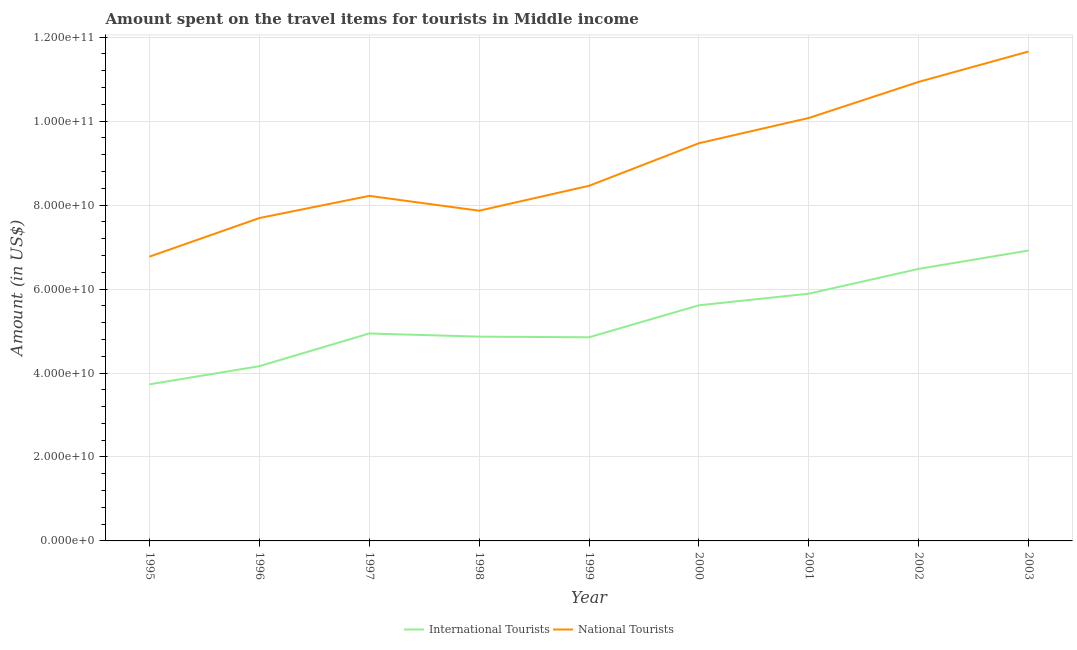How many different coloured lines are there?
Make the answer very short. 2. Does the line corresponding to amount spent on travel items of national tourists intersect with the line corresponding to amount spent on travel items of international tourists?
Ensure brevity in your answer.  No. What is the amount spent on travel items of international tourists in 1996?
Offer a terse response. 4.16e+1. Across all years, what is the maximum amount spent on travel items of national tourists?
Provide a succinct answer. 1.17e+11. Across all years, what is the minimum amount spent on travel items of international tourists?
Give a very brief answer. 3.73e+1. In which year was the amount spent on travel items of international tourists maximum?
Give a very brief answer. 2003. In which year was the amount spent on travel items of international tourists minimum?
Make the answer very short. 1995. What is the total amount spent on travel items of national tourists in the graph?
Keep it short and to the point. 8.11e+11. What is the difference between the amount spent on travel items of international tourists in 1997 and that in 1999?
Offer a very short reply. 9.06e+08. What is the difference between the amount spent on travel items of international tourists in 2001 and the amount spent on travel items of national tourists in 1995?
Your response must be concise. -8.82e+09. What is the average amount spent on travel items of international tourists per year?
Provide a succinct answer. 5.27e+1. In the year 2000, what is the difference between the amount spent on travel items of national tourists and amount spent on travel items of international tourists?
Provide a short and direct response. 3.86e+1. What is the ratio of the amount spent on travel items of international tourists in 1995 to that in 2000?
Your response must be concise. 0.66. What is the difference between the highest and the second highest amount spent on travel items of national tourists?
Your answer should be very brief. 7.23e+09. What is the difference between the highest and the lowest amount spent on travel items of national tourists?
Your response must be concise. 4.89e+1. In how many years, is the amount spent on travel items of national tourists greater than the average amount spent on travel items of national tourists taken over all years?
Your answer should be very brief. 4. Does the amount spent on travel items of international tourists monotonically increase over the years?
Your answer should be compact. No. Are the values on the major ticks of Y-axis written in scientific E-notation?
Keep it short and to the point. Yes. Does the graph contain any zero values?
Provide a succinct answer. No. Does the graph contain grids?
Make the answer very short. Yes. What is the title of the graph?
Offer a very short reply. Amount spent on the travel items for tourists in Middle income. What is the label or title of the X-axis?
Provide a short and direct response. Year. What is the Amount (in US$) of International Tourists in 1995?
Provide a succinct answer. 3.73e+1. What is the Amount (in US$) of National Tourists in 1995?
Your response must be concise. 6.77e+1. What is the Amount (in US$) of International Tourists in 1996?
Your answer should be very brief. 4.16e+1. What is the Amount (in US$) of National Tourists in 1996?
Keep it short and to the point. 7.69e+1. What is the Amount (in US$) of International Tourists in 1997?
Offer a very short reply. 4.94e+1. What is the Amount (in US$) of National Tourists in 1997?
Offer a very short reply. 8.22e+1. What is the Amount (in US$) of International Tourists in 1998?
Your answer should be very brief. 4.87e+1. What is the Amount (in US$) of National Tourists in 1998?
Your response must be concise. 7.87e+1. What is the Amount (in US$) in International Tourists in 1999?
Keep it short and to the point. 4.85e+1. What is the Amount (in US$) of National Tourists in 1999?
Your response must be concise. 8.46e+1. What is the Amount (in US$) of International Tourists in 2000?
Your answer should be compact. 5.61e+1. What is the Amount (in US$) in National Tourists in 2000?
Keep it short and to the point. 9.47e+1. What is the Amount (in US$) of International Tourists in 2001?
Keep it short and to the point. 5.89e+1. What is the Amount (in US$) in National Tourists in 2001?
Your answer should be very brief. 1.01e+11. What is the Amount (in US$) of International Tourists in 2002?
Keep it short and to the point. 6.48e+1. What is the Amount (in US$) in National Tourists in 2002?
Your response must be concise. 1.09e+11. What is the Amount (in US$) in International Tourists in 2003?
Provide a short and direct response. 6.92e+1. What is the Amount (in US$) in National Tourists in 2003?
Provide a short and direct response. 1.17e+11. Across all years, what is the maximum Amount (in US$) in International Tourists?
Provide a short and direct response. 6.92e+1. Across all years, what is the maximum Amount (in US$) in National Tourists?
Ensure brevity in your answer.  1.17e+11. Across all years, what is the minimum Amount (in US$) of International Tourists?
Your response must be concise. 3.73e+1. Across all years, what is the minimum Amount (in US$) of National Tourists?
Keep it short and to the point. 6.77e+1. What is the total Amount (in US$) in International Tourists in the graph?
Give a very brief answer. 4.75e+11. What is the total Amount (in US$) in National Tourists in the graph?
Provide a succinct answer. 8.11e+11. What is the difference between the Amount (in US$) of International Tourists in 1995 and that in 1996?
Keep it short and to the point. -4.33e+09. What is the difference between the Amount (in US$) of National Tourists in 1995 and that in 1996?
Give a very brief answer. -9.19e+09. What is the difference between the Amount (in US$) of International Tourists in 1995 and that in 1997?
Give a very brief answer. -1.21e+1. What is the difference between the Amount (in US$) in National Tourists in 1995 and that in 1997?
Provide a succinct answer. -1.45e+1. What is the difference between the Amount (in US$) in International Tourists in 1995 and that in 1998?
Provide a short and direct response. -1.14e+1. What is the difference between the Amount (in US$) of National Tourists in 1995 and that in 1998?
Ensure brevity in your answer.  -1.09e+1. What is the difference between the Amount (in US$) of International Tourists in 1995 and that in 1999?
Your response must be concise. -1.12e+1. What is the difference between the Amount (in US$) in National Tourists in 1995 and that in 1999?
Ensure brevity in your answer.  -1.69e+1. What is the difference between the Amount (in US$) of International Tourists in 1995 and that in 2000?
Keep it short and to the point. -1.88e+1. What is the difference between the Amount (in US$) of National Tourists in 1995 and that in 2000?
Your answer should be very brief. -2.70e+1. What is the difference between the Amount (in US$) of International Tourists in 1995 and that in 2001?
Ensure brevity in your answer.  -2.16e+1. What is the difference between the Amount (in US$) in National Tourists in 1995 and that in 2001?
Offer a terse response. -3.30e+1. What is the difference between the Amount (in US$) of International Tourists in 1995 and that in 2002?
Give a very brief answer. -2.75e+1. What is the difference between the Amount (in US$) in National Tourists in 1995 and that in 2002?
Offer a terse response. -4.16e+1. What is the difference between the Amount (in US$) in International Tourists in 1995 and that in 2003?
Your response must be concise. -3.19e+1. What is the difference between the Amount (in US$) of National Tourists in 1995 and that in 2003?
Ensure brevity in your answer.  -4.89e+1. What is the difference between the Amount (in US$) in International Tourists in 1996 and that in 1997?
Your answer should be compact. -7.79e+09. What is the difference between the Amount (in US$) in National Tourists in 1996 and that in 1997?
Provide a succinct answer. -5.28e+09. What is the difference between the Amount (in US$) of International Tourists in 1996 and that in 1998?
Your response must be concise. -7.04e+09. What is the difference between the Amount (in US$) in National Tourists in 1996 and that in 1998?
Give a very brief answer. -1.75e+09. What is the difference between the Amount (in US$) in International Tourists in 1996 and that in 1999?
Your answer should be very brief. -6.88e+09. What is the difference between the Amount (in US$) of National Tourists in 1996 and that in 1999?
Give a very brief answer. -7.68e+09. What is the difference between the Amount (in US$) of International Tourists in 1996 and that in 2000?
Keep it short and to the point. -1.45e+1. What is the difference between the Amount (in US$) in National Tourists in 1996 and that in 2000?
Ensure brevity in your answer.  -1.78e+1. What is the difference between the Amount (in US$) in International Tourists in 1996 and that in 2001?
Offer a very short reply. -1.73e+1. What is the difference between the Amount (in US$) in National Tourists in 1996 and that in 2001?
Give a very brief answer. -2.38e+1. What is the difference between the Amount (in US$) of International Tourists in 1996 and that in 2002?
Offer a terse response. -2.32e+1. What is the difference between the Amount (in US$) of National Tourists in 1996 and that in 2002?
Offer a very short reply. -3.24e+1. What is the difference between the Amount (in US$) in International Tourists in 1996 and that in 2003?
Make the answer very short. -2.76e+1. What is the difference between the Amount (in US$) in National Tourists in 1996 and that in 2003?
Your response must be concise. -3.97e+1. What is the difference between the Amount (in US$) in International Tourists in 1997 and that in 1998?
Your answer should be compact. 7.52e+08. What is the difference between the Amount (in US$) of National Tourists in 1997 and that in 1998?
Provide a short and direct response. 3.53e+09. What is the difference between the Amount (in US$) in International Tourists in 1997 and that in 1999?
Give a very brief answer. 9.06e+08. What is the difference between the Amount (in US$) in National Tourists in 1997 and that in 1999?
Offer a very short reply. -2.40e+09. What is the difference between the Amount (in US$) in International Tourists in 1997 and that in 2000?
Give a very brief answer. -6.71e+09. What is the difference between the Amount (in US$) of National Tourists in 1997 and that in 2000?
Offer a very short reply. -1.25e+1. What is the difference between the Amount (in US$) of International Tourists in 1997 and that in 2001?
Make the answer very short. -9.48e+09. What is the difference between the Amount (in US$) of National Tourists in 1997 and that in 2001?
Offer a very short reply. -1.86e+1. What is the difference between the Amount (in US$) of International Tourists in 1997 and that in 2002?
Provide a short and direct response. -1.54e+1. What is the difference between the Amount (in US$) of National Tourists in 1997 and that in 2002?
Provide a succinct answer. -2.72e+1. What is the difference between the Amount (in US$) in International Tourists in 1997 and that in 2003?
Provide a succinct answer. -1.98e+1. What is the difference between the Amount (in US$) of National Tourists in 1997 and that in 2003?
Give a very brief answer. -3.44e+1. What is the difference between the Amount (in US$) of International Tourists in 1998 and that in 1999?
Offer a very short reply. 1.54e+08. What is the difference between the Amount (in US$) of National Tourists in 1998 and that in 1999?
Provide a succinct answer. -5.93e+09. What is the difference between the Amount (in US$) of International Tourists in 1998 and that in 2000?
Provide a short and direct response. -7.47e+09. What is the difference between the Amount (in US$) of National Tourists in 1998 and that in 2000?
Provide a succinct answer. -1.61e+1. What is the difference between the Amount (in US$) of International Tourists in 1998 and that in 2001?
Make the answer very short. -1.02e+1. What is the difference between the Amount (in US$) in National Tourists in 1998 and that in 2001?
Your answer should be very brief. -2.21e+1. What is the difference between the Amount (in US$) of International Tourists in 1998 and that in 2002?
Offer a terse response. -1.61e+1. What is the difference between the Amount (in US$) in National Tourists in 1998 and that in 2002?
Your answer should be compact. -3.07e+1. What is the difference between the Amount (in US$) in International Tourists in 1998 and that in 2003?
Your answer should be very brief. -2.05e+1. What is the difference between the Amount (in US$) in National Tourists in 1998 and that in 2003?
Keep it short and to the point. -3.79e+1. What is the difference between the Amount (in US$) of International Tourists in 1999 and that in 2000?
Provide a succinct answer. -7.62e+09. What is the difference between the Amount (in US$) of National Tourists in 1999 and that in 2000?
Provide a succinct answer. -1.01e+1. What is the difference between the Amount (in US$) of International Tourists in 1999 and that in 2001?
Your answer should be very brief. -1.04e+1. What is the difference between the Amount (in US$) of National Tourists in 1999 and that in 2001?
Offer a very short reply. -1.62e+1. What is the difference between the Amount (in US$) in International Tourists in 1999 and that in 2002?
Keep it short and to the point. -1.63e+1. What is the difference between the Amount (in US$) of National Tourists in 1999 and that in 2002?
Your response must be concise. -2.48e+1. What is the difference between the Amount (in US$) of International Tourists in 1999 and that in 2003?
Your response must be concise. -2.07e+1. What is the difference between the Amount (in US$) of National Tourists in 1999 and that in 2003?
Make the answer very short. -3.20e+1. What is the difference between the Amount (in US$) of International Tourists in 2000 and that in 2001?
Provide a short and direct response. -2.77e+09. What is the difference between the Amount (in US$) in National Tourists in 2000 and that in 2001?
Your answer should be compact. -6.01e+09. What is the difference between the Amount (in US$) of International Tourists in 2000 and that in 2002?
Your answer should be very brief. -8.68e+09. What is the difference between the Amount (in US$) in National Tourists in 2000 and that in 2002?
Your answer should be very brief. -1.46e+1. What is the difference between the Amount (in US$) of International Tourists in 2000 and that in 2003?
Give a very brief answer. -1.31e+1. What is the difference between the Amount (in US$) of National Tourists in 2000 and that in 2003?
Your answer should be very brief. -2.18e+1. What is the difference between the Amount (in US$) of International Tourists in 2001 and that in 2002?
Offer a terse response. -5.91e+09. What is the difference between the Amount (in US$) of National Tourists in 2001 and that in 2002?
Your answer should be very brief. -8.60e+09. What is the difference between the Amount (in US$) in International Tourists in 2001 and that in 2003?
Provide a short and direct response. -1.03e+1. What is the difference between the Amount (in US$) of National Tourists in 2001 and that in 2003?
Your answer should be compact. -1.58e+1. What is the difference between the Amount (in US$) in International Tourists in 2002 and that in 2003?
Give a very brief answer. -4.37e+09. What is the difference between the Amount (in US$) in National Tourists in 2002 and that in 2003?
Your answer should be very brief. -7.23e+09. What is the difference between the Amount (in US$) of International Tourists in 1995 and the Amount (in US$) of National Tourists in 1996?
Keep it short and to the point. -3.96e+1. What is the difference between the Amount (in US$) of International Tourists in 1995 and the Amount (in US$) of National Tourists in 1997?
Ensure brevity in your answer.  -4.49e+1. What is the difference between the Amount (in US$) in International Tourists in 1995 and the Amount (in US$) in National Tourists in 1998?
Provide a short and direct response. -4.14e+1. What is the difference between the Amount (in US$) in International Tourists in 1995 and the Amount (in US$) in National Tourists in 1999?
Offer a terse response. -4.73e+1. What is the difference between the Amount (in US$) of International Tourists in 1995 and the Amount (in US$) of National Tourists in 2000?
Your answer should be very brief. -5.74e+1. What is the difference between the Amount (in US$) in International Tourists in 1995 and the Amount (in US$) in National Tourists in 2001?
Your answer should be compact. -6.34e+1. What is the difference between the Amount (in US$) of International Tourists in 1995 and the Amount (in US$) of National Tourists in 2002?
Offer a very short reply. -7.20e+1. What is the difference between the Amount (in US$) in International Tourists in 1995 and the Amount (in US$) in National Tourists in 2003?
Offer a terse response. -7.93e+1. What is the difference between the Amount (in US$) of International Tourists in 1996 and the Amount (in US$) of National Tourists in 1997?
Provide a succinct answer. -4.06e+1. What is the difference between the Amount (in US$) in International Tourists in 1996 and the Amount (in US$) in National Tourists in 1998?
Ensure brevity in your answer.  -3.70e+1. What is the difference between the Amount (in US$) in International Tourists in 1996 and the Amount (in US$) in National Tourists in 1999?
Provide a succinct answer. -4.30e+1. What is the difference between the Amount (in US$) in International Tourists in 1996 and the Amount (in US$) in National Tourists in 2000?
Ensure brevity in your answer.  -5.31e+1. What is the difference between the Amount (in US$) in International Tourists in 1996 and the Amount (in US$) in National Tourists in 2001?
Ensure brevity in your answer.  -5.91e+1. What is the difference between the Amount (in US$) in International Tourists in 1996 and the Amount (in US$) in National Tourists in 2002?
Keep it short and to the point. -6.77e+1. What is the difference between the Amount (in US$) in International Tourists in 1996 and the Amount (in US$) in National Tourists in 2003?
Make the answer very short. -7.50e+1. What is the difference between the Amount (in US$) of International Tourists in 1997 and the Amount (in US$) of National Tourists in 1998?
Your answer should be compact. -2.92e+1. What is the difference between the Amount (in US$) of International Tourists in 1997 and the Amount (in US$) of National Tourists in 1999?
Make the answer very short. -3.52e+1. What is the difference between the Amount (in US$) in International Tourists in 1997 and the Amount (in US$) in National Tourists in 2000?
Your response must be concise. -4.53e+1. What is the difference between the Amount (in US$) in International Tourists in 1997 and the Amount (in US$) in National Tourists in 2001?
Offer a terse response. -5.13e+1. What is the difference between the Amount (in US$) of International Tourists in 1997 and the Amount (in US$) of National Tourists in 2002?
Your answer should be very brief. -5.99e+1. What is the difference between the Amount (in US$) of International Tourists in 1997 and the Amount (in US$) of National Tourists in 2003?
Offer a very short reply. -6.72e+1. What is the difference between the Amount (in US$) of International Tourists in 1998 and the Amount (in US$) of National Tourists in 1999?
Keep it short and to the point. -3.59e+1. What is the difference between the Amount (in US$) of International Tourists in 1998 and the Amount (in US$) of National Tourists in 2000?
Offer a very short reply. -4.61e+1. What is the difference between the Amount (in US$) in International Tourists in 1998 and the Amount (in US$) in National Tourists in 2001?
Your response must be concise. -5.21e+1. What is the difference between the Amount (in US$) of International Tourists in 1998 and the Amount (in US$) of National Tourists in 2002?
Your answer should be compact. -6.07e+1. What is the difference between the Amount (in US$) in International Tourists in 1998 and the Amount (in US$) in National Tourists in 2003?
Ensure brevity in your answer.  -6.79e+1. What is the difference between the Amount (in US$) of International Tourists in 1999 and the Amount (in US$) of National Tourists in 2000?
Keep it short and to the point. -4.62e+1. What is the difference between the Amount (in US$) of International Tourists in 1999 and the Amount (in US$) of National Tourists in 2001?
Make the answer very short. -5.22e+1. What is the difference between the Amount (in US$) of International Tourists in 1999 and the Amount (in US$) of National Tourists in 2002?
Your response must be concise. -6.08e+1. What is the difference between the Amount (in US$) of International Tourists in 1999 and the Amount (in US$) of National Tourists in 2003?
Keep it short and to the point. -6.81e+1. What is the difference between the Amount (in US$) of International Tourists in 2000 and the Amount (in US$) of National Tourists in 2001?
Offer a very short reply. -4.46e+1. What is the difference between the Amount (in US$) in International Tourists in 2000 and the Amount (in US$) in National Tourists in 2002?
Provide a succinct answer. -5.32e+1. What is the difference between the Amount (in US$) of International Tourists in 2000 and the Amount (in US$) of National Tourists in 2003?
Your answer should be compact. -6.05e+1. What is the difference between the Amount (in US$) in International Tourists in 2001 and the Amount (in US$) in National Tourists in 2002?
Make the answer very short. -5.05e+1. What is the difference between the Amount (in US$) of International Tourists in 2001 and the Amount (in US$) of National Tourists in 2003?
Make the answer very short. -5.77e+1. What is the difference between the Amount (in US$) in International Tourists in 2002 and the Amount (in US$) in National Tourists in 2003?
Your response must be concise. -5.18e+1. What is the average Amount (in US$) in International Tourists per year?
Ensure brevity in your answer.  5.27e+1. What is the average Amount (in US$) of National Tourists per year?
Provide a short and direct response. 9.02e+1. In the year 1995, what is the difference between the Amount (in US$) of International Tourists and Amount (in US$) of National Tourists?
Keep it short and to the point. -3.04e+1. In the year 1996, what is the difference between the Amount (in US$) in International Tourists and Amount (in US$) in National Tourists?
Your answer should be very brief. -3.53e+1. In the year 1997, what is the difference between the Amount (in US$) of International Tourists and Amount (in US$) of National Tourists?
Your answer should be compact. -3.28e+1. In the year 1998, what is the difference between the Amount (in US$) of International Tourists and Amount (in US$) of National Tourists?
Ensure brevity in your answer.  -3.00e+1. In the year 1999, what is the difference between the Amount (in US$) in International Tourists and Amount (in US$) in National Tourists?
Provide a short and direct response. -3.61e+1. In the year 2000, what is the difference between the Amount (in US$) of International Tourists and Amount (in US$) of National Tourists?
Provide a short and direct response. -3.86e+1. In the year 2001, what is the difference between the Amount (in US$) of International Tourists and Amount (in US$) of National Tourists?
Your answer should be very brief. -4.19e+1. In the year 2002, what is the difference between the Amount (in US$) of International Tourists and Amount (in US$) of National Tourists?
Your response must be concise. -4.45e+1. In the year 2003, what is the difference between the Amount (in US$) of International Tourists and Amount (in US$) of National Tourists?
Ensure brevity in your answer.  -4.74e+1. What is the ratio of the Amount (in US$) in International Tourists in 1995 to that in 1996?
Make the answer very short. 0.9. What is the ratio of the Amount (in US$) of National Tourists in 1995 to that in 1996?
Ensure brevity in your answer.  0.88. What is the ratio of the Amount (in US$) of International Tourists in 1995 to that in 1997?
Your response must be concise. 0.75. What is the ratio of the Amount (in US$) in National Tourists in 1995 to that in 1997?
Your answer should be very brief. 0.82. What is the ratio of the Amount (in US$) in International Tourists in 1995 to that in 1998?
Provide a short and direct response. 0.77. What is the ratio of the Amount (in US$) of National Tourists in 1995 to that in 1998?
Your answer should be compact. 0.86. What is the ratio of the Amount (in US$) in International Tourists in 1995 to that in 1999?
Keep it short and to the point. 0.77. What is the ratio of the Amount (in US$) of National Tourists in 1995 to that in 1999?
Make the answer very short. 0.8. What is the ratio of the Amount (in US$) of International Tourists in 1995 to that in 2000?
Ensure brevity in your answer.  0.66. What is the ratio of the Amount (in US$) in National Tourists in 1995 to that in 2000?
Offer a terse response. 0.71. What is the ratio of the Amount (in US$) in International Tourists in 1995 to that in 2001?
Keep it short and to the point. 0.63. What is the ratio of the Amount (in US$) of National Tourists in 1995 to that in 2001?
Offer a terse response. 0.67. What is the ratio of the Amount (in US$) in International Tourists in 1995 to that in 2002?
Provide a succinct answer. 0.58. What is the ratio of the Amount (in US$) in National Tourists in 1995 to that in 2002?
Give a very brief answer. 0.62. What is the ratio of the Amount (in US$) in International Tourists in 1995 to that in 2003?
Keep it short and to the point. 0.54. What is the ratio of the Amount (in US$) in National Tourists in 1995 to that in 2003?
Your response must be concise. 0.58. What is the ratio of the Amount (in US$) in International Tourists in 1996 to that in 1997?
Your response must be concise. 0.84. What is the ratio of the Amount (in US$) in National Tourists in 1996 to that in 1997?
Keep it short and to the point. 0.94. What is the ratio of the Amount (in US$) of International Tourists in 1996 to that in 1998?
Your answer should be compact. 0.86. What is the ratio of the Amount (in US$) of National Tourists in 1996 to that in 1998?
Ensure brevity in your answer.  0.98. What is the ratio of the Amount (in US$) in International Tourists in 1996 to that in 1999?
Your response must be concise. 0.86. What is the ratio of the Amount (in US$) in National Tourists in 1996 to that in 1999?
Your answer should be very brief. 0.91. What is the ratio of the Amount (in US$) in International Tourists in 1996 to that in 2000?
Provide a short and direct response. 0.74. What is the ratio of the Amount (in US$) of National Tourists in 1996 to that in 2000?
Your response must be concise. 0.81. What is the ratio of the Amount (in US$) of International Tourists in 1996 to that in 2001?
Your response must be concise. 0.71. What is the ratio of the Amount (in US$) in National Tourists in 1996 to that in 2001?
Your response must be concise. 0.76. What is the ratio of the Amount (in US$) in International Tourists in 1996 to that in 2002?
Offer a very short reply. 0.64. What is the ratio of the Amount (in US$) of National Tourists in 1996 to that in 2002?
Your response must be concise. 0.7. What is the ratio of the Amount (in US$) of International Tourists in 1996 to that in 2003?
Your answer should be very brief. 0.6. What is the ratio of the Amount (in US$) in National Tourists in 1996 to that in 2003?
Offer a terse response. 0.66. What is the ratio of the Amount (in US$) of International Tourists in 1997 to that in 1998?
Give a very brief answer. 1.02. What is the ratio of the Amount (in US$) in National Tourists in 1997 to that in 1998?
Give a very brief answer. 1.04. What is the ratio of the Amount (in US$) in International Tourists in 1997 to that in 1999?
Your answer should be very brief. 1.02. What is the ratio of the Amount (in US$) of National Tourists in 1997 to that in 1999?
Your response must be concise. 0.97. What is the ratio of the Amount (in US$) in International Tourists in 1997 to that in 2000?
Your answer should be compact. 0.88. What is the ratio of the Amount (in US$) of National Tourists in 1997 to that in 2000?
Offer a terse response. 0.87. What is the ratio of the Amount (in US$) of International Tourists in 1997 to that in 2001?
Your answer should be compact. 0.84. What is the ratio of the Amount (in US$) in National Tourists in 1997 to that in 2001?
Ensure brevity in your answer.  0.82. What is the ratio of the Amount (in US$) of International Tourists in 1997 to that in 2002?
Your answer should be compact. 0.76. What is the ratio of the Amount (in US$) in National Tourists in 1997 to that in 2002?
Your response must be concise. 0.75. What is the ratio of the Amount (in US$) of National Tourists in 1997 to that in 2003?
Make the answer very short. 0.7. What is the ratio of the Amount (in US$) in International Tourists in 1998 to that in 1999?
Provide a short and direct response. 1. What is the ratio of the Amount (in US$) in National Tourists in 1998 to that in 1999?
Offer a terse response. 0.93. What is the ratio of the Amount (in US$) of International Tourists in 1998 to that in 2000?
Provide a succinct answer. 0.87. What is the ratio of the Amount (in US$) of National Tourists in 1998 to that in 2000?
Ensure brevity in your answer.  0.83. What is the ratio of the Amount (in US$) in International Tourists in 1998 to that in 2001?
Provide a short and direct response. 0.83. What is the ratio of the Amount (in US$) of National Tourists in 1998 to that in 2001?
Offer a very short reply. 0.78. What is the ratio of the Amount (in US$) of International Tourists in 1998 to that in 2002?
Your answer should be very brief. 0.75. What is the ratio of the Amount (in US$) of National Tourists in 1998 to that in 2002?
Provide a succinct answer. 0.72. What is the ratio of the Amount (in US$) of International Tourists in 1998 to that in 2003?
Provide a short and direct response. 0.7. What is the ratio of the Amount (in US$) of National Tourists in 1998 to that in 2003?
Your answer should be very brief. 0.67. What is the ratio of the Amount (in US$) in International Tourists in 1999 to that in 2000?
Give a very brief answer. 0.86. What is the ratio of the Amount (in US$) in National Tourists in 1999 to that in 2000?
Your answer should be very brief. 0.89. What is the ratio of the Amount (in US$) in International Tourists in 1999 to that in 2001?
Give a very brief answer. 0.82. What is the ratio of the Amount (in US$) of National Tourists in 1999 to that in 2001?
Your answer should be compact. 0.84. What is the ratio of the Amount (in US$) of International Tourists in 1999 to that in 2002?
Your response must be concise. 0.75. What is the ratio of the Amount (in US$) in National Tourists in 1999 to that in 2002?
Your answer should be very brief. 0.77. What is the ratio of the Amount (in US$) of International Tourists in 1999 to that in 2003?
Your answer should be very brief. 0.7. What is the ratio of the Amount (in US$) in National Tourists in 1999 to that in 2003?
Give a very brief answer. 0.73. What is the ratio of the Amount (in US$) of International Tourists in 2000 to that in 2001?
Offer a very short reply. 0.95. What is the ratio of the Amount (in US$) in National Tourists in 2000 to that in 2001?
Your response must be concise. 0.94. What is the ratio of the Amount (in US$) of International Tourists in 2000 to that in 2002?
Ensure brevity in your answer.  0.87. What is the ratio of the Amount (in US$) in National Tourists in 2000 to that in 2002?
Give a very brief answer. 0.87. What is the ratio of the Amount (in US$) of International Tourists in 2000 to that in 2003?
Make the answer very short. 0.81. What is the ratio of the Amount (in US$) of National Tourists in 2000 to that in 2003?
Give a very brief answer. 0.81. What is the ratio of the Amount (in US$) of International Tourists in 2001 to that in 2002?
Make the answer very short. 0.91. What is the ratio of the Amount (in US$) in National Tourists in 2001 to that in 2002?
Provide a short and direct response. 0.92. What is the ratio of the Amount (in US$) of International Tourists in 2001 to that in 2003?
Give a very brief answer. 0.85. What is the ratio of the Amount (in US$) in National Tourists in 2001 to that in 2003?
Provide a short and direct response. 0.86. What is the ratio of the Amount (in US$) in International Tourists in 2002 to that in 2003?
Your answer should be compact. 0.94. What is the ratio of the Amount (in US$) of National Tourists in 2002 to that in 2003?
Keep it short and to the point. 0.94. What is the difference between the highest and the second highest Amount (in US$) in International Tourists?
Keep it short and to the point. 4.37e+09. What is the difference between the highest and the second highest Amount (in US$) in National Tourists?
Offer a very short reply. 7.23e+09. What is the difference between the highest and the lowest Amount (in US$) in International Tourists?
Ensure brevity in your answer.  3.19e+1. What is the difference between the highest and the lowest Amount (in US$) of National Tourists?
Ensure brevity in your answer.  4.89e+1. 